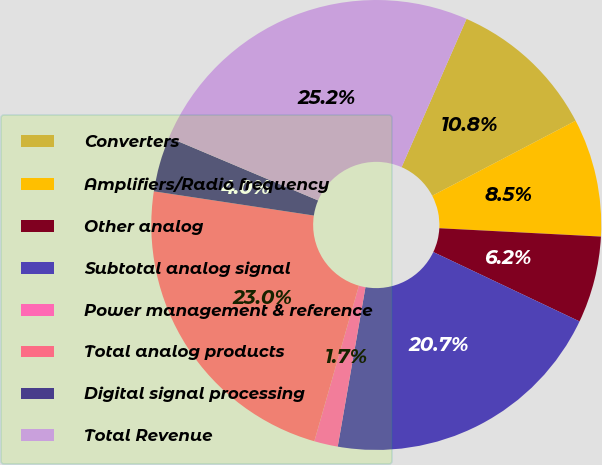<chart> <loc_0><loc_0><loc_500><loc_500><pie_chart><fcel>Converters<fcel>Amplifiers/Radio frequency<fcel>Other analog<fcel>Subtotal analog signal<fcel>Power management & reference<fcel>Total analog products<fcel>Digital signal processing<fcel>Total Revenue<nl><fcel>10.76%<fcel>8.49%<fcel>6.23%<fcel>20.69%<fcel>1.7%<fcel>22.95%<fcel>3.97%<fcel>25.21%<nl></chart> 